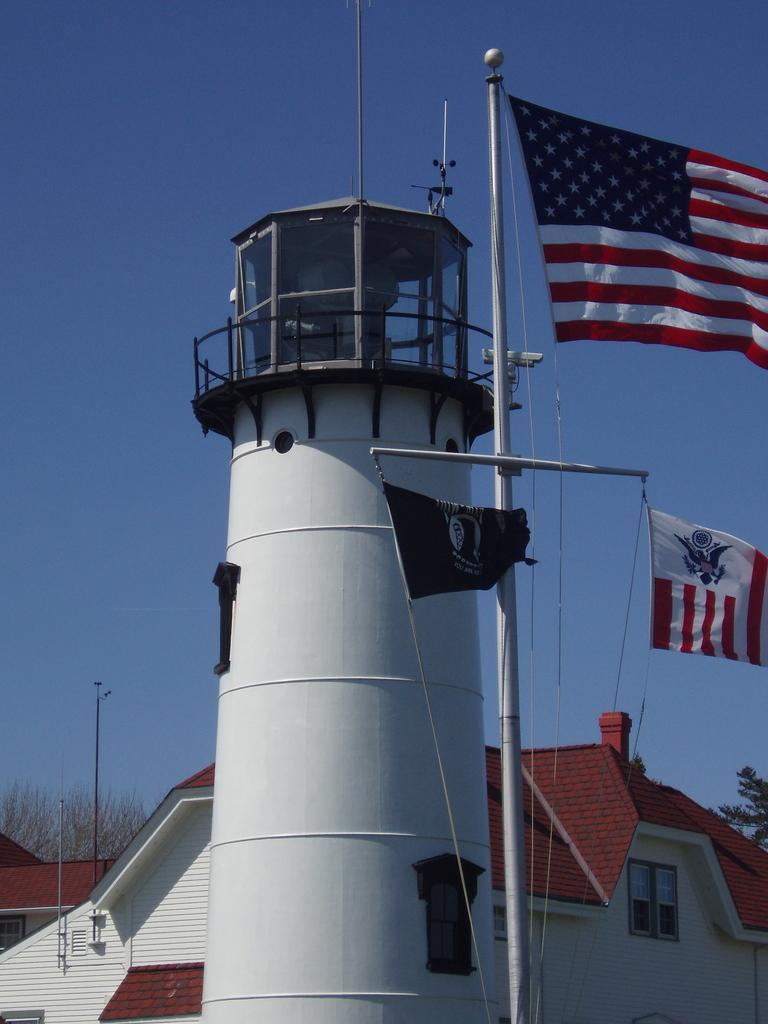What types of structures can be seen in the image? There are buildings and houses in the image. What color are the rooftops of some structures in the image? The rooftops of some structures in the image are red. What type of vegetation is present in the image? There are trees in the image. What other objects can be seen in the image? There are flags in the image. What part of the natural environment is visible in the image? The sky is visible in the image. What type of furniture is visible in the image? There is no furniture present in the image; it primarily features buildings, houses, trees, flags, and the sky. How many cherries can be seen hanging from the trees in the image? There are no cherries present in the image; the trees are not specified as fruit-bearing trees. 